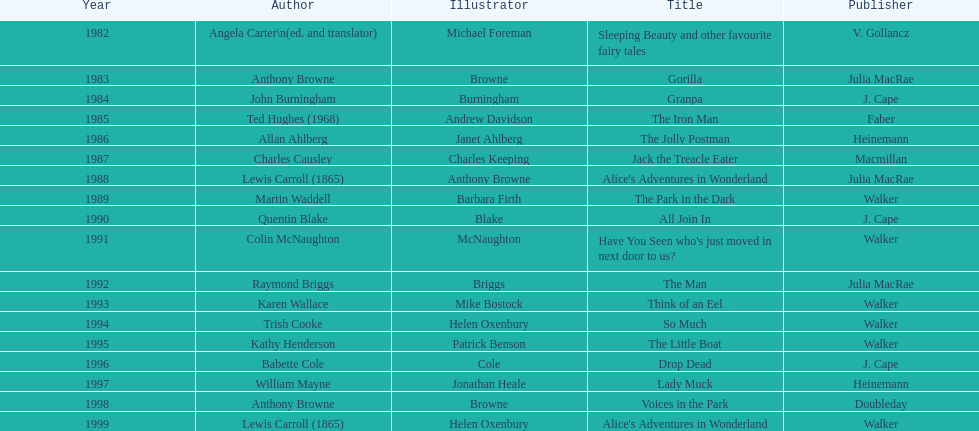How many times has anthony browne received a kurt maschler award for illustration? 3. 